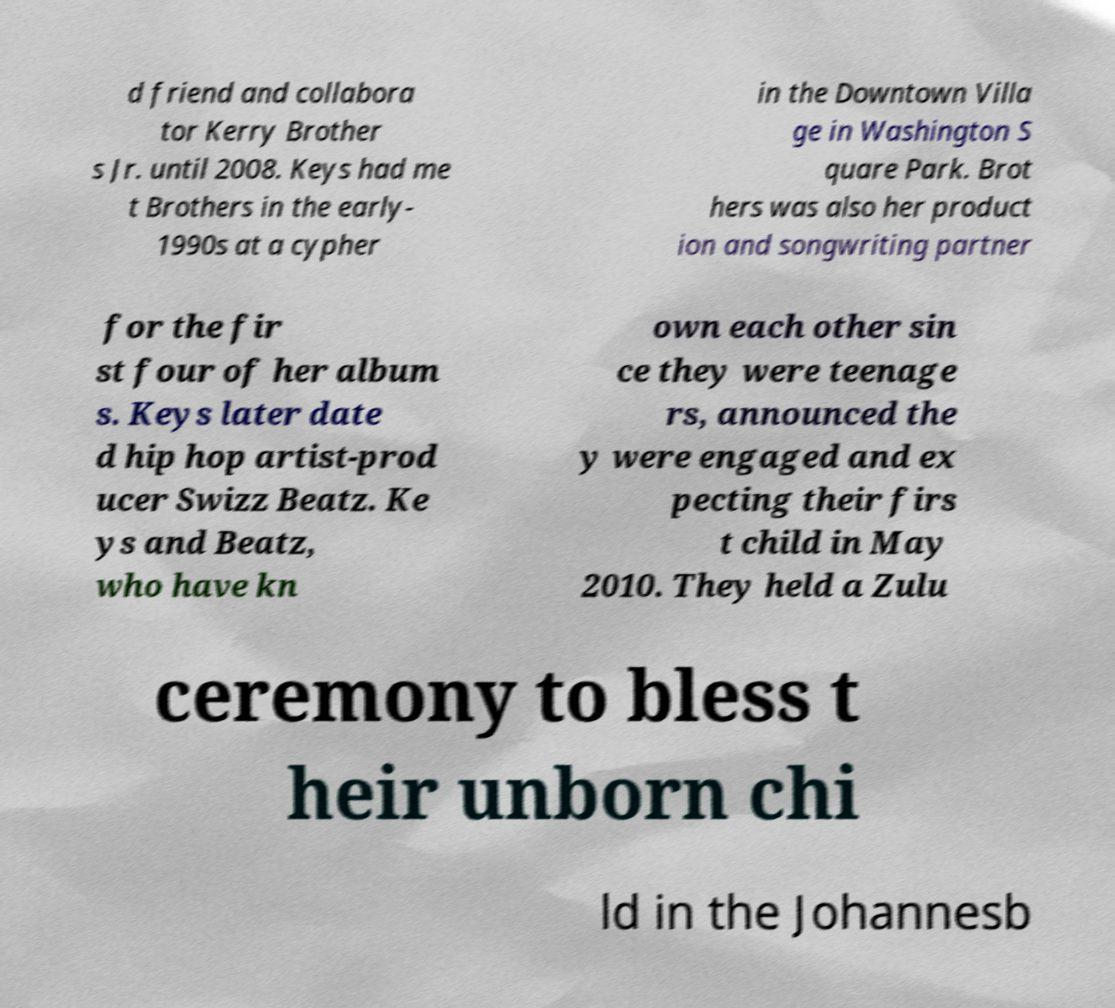Could you assist in decoding the text presented in this image and type it out clearly? d friend and collabora tor Kerry Brother s Jr. until 2008. Keys had me t Brothers in the early- 1990s at a cypher in the Downtown Villa ge in Washington S quare Park. Brot hers was also her product ion and songwriting partner for the fir st four of her album s. Keys later date d hip hop artist-prod ucer Swizz Beatz. Ke ys and Beatz, who have kn own each other sin ce they were teenage rs, announced the y were engaged and ex pecting their firs t child in May 2010. They held a Zulu ceremony to bless t heir unborn chi ld in the Johannesb 